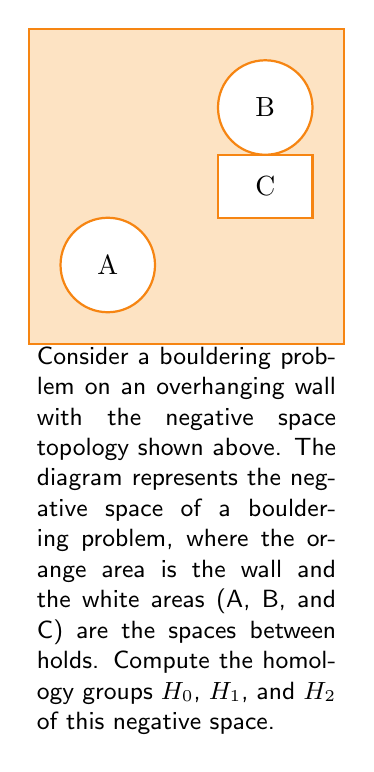Could you help me with this problem? Let's approach this step-by-step:

1) First, we need to understand what we're looking at:
   - We have a 2-dimensional surface (the wall)
   - There are three distinct "holes" in this surface (A, B, and C)

2) Now, let's compute the homology groups:

   a) $H_0$: This group counts the number of connected components.
      - Our space is connected (all white areas are part of one component)
      - Therefore, $H_0 \cong \mathbb{Z}$

   b) $H_1$: This group counts the number of 1-dimensional holes (loops).
      - We have three holes: A, B, and C
      - Each of these contributes to $H_1$
      - Therefore, $H_1 \cong \mathbb{Z} \oplus \mathbb{Z} \oplus \mathbb{Z}$

   c) $H_2$: This group counts the number of 2-dimensional voids.
      - Our space is essentially a 2D surface, so there are no 2D voids
      - Therefore, $H_2 \cong 0$

3) In topological terms, our space is homotopy equivalent to a wedge sum of three circles.

4) The Betti numbers for this space are:
   $b_0 = 1$, $b_1 = 3$, $b_2 = 0$

These Betti numbers confirm our homology group calculations.
Answer: $H_0 \cong \mathbb{Z}$, $H_1 \cong \mathbb{Z}^3$, $H_2 \cong 0$ 